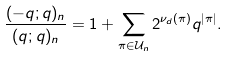<formula> <loc_0><loc_0><loc_500><loc_500>\frac { ( - q ; q ) _ { n } } { ( q ; q ) _ { n } } = 1 + \sum _ { \pi \in \mathcal { U } _ { n } } 2 ^ { \nu _ { d } ( \pi ) } q ^ { | \pi | } .</formula> 